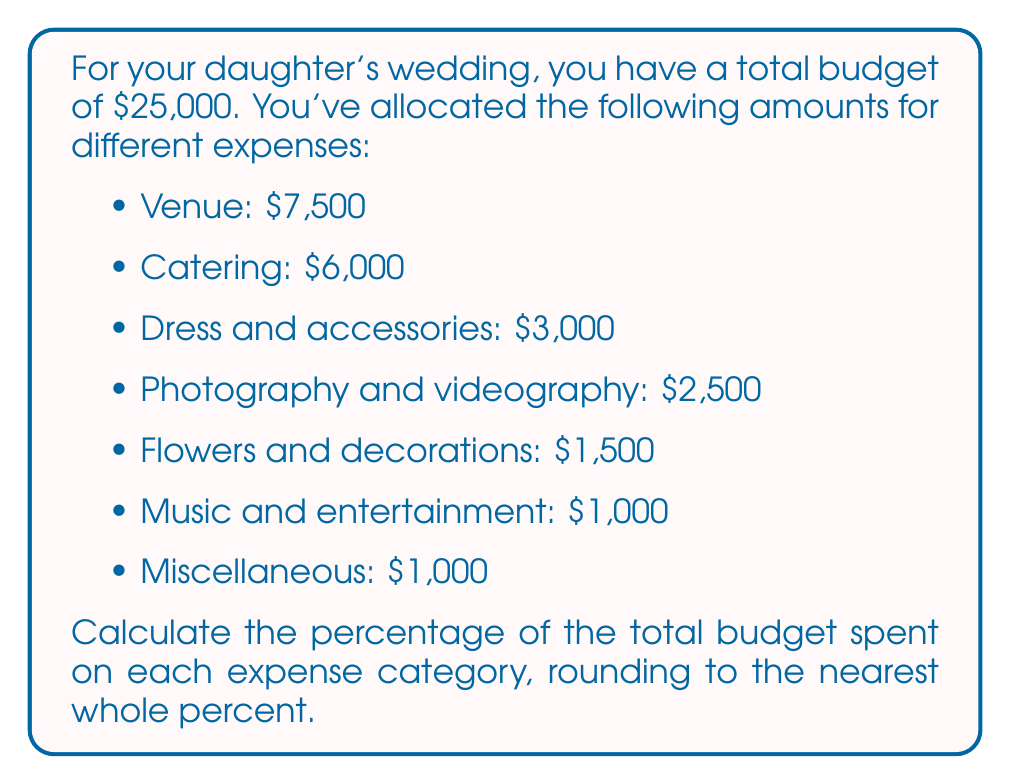Teach me how to tackle this problem. To calculate the percentage of the total budget spent on each expense category, we'll use the formula:

$$ \text{Percentage} = \frac{\text{Expense amount}}{\text{Total budget}} \times 100\% $$

Let's calculate for each category:

1. Venue:
   $$ \frac{7500}{25000} \times 100\% = 30\% $$

2. Catering:
   $$ \frac{6000}{25000} \times 100\% = 24\% $$

3. Dress and accessories:
   $$ \frac{3000}{25000} \times 100\% = 12\% $$

4. Photography and videography:
   $$ \frac{2500}{25000} \times 100\% = 10\% $$

5. Flowers and decorations:
   $$ \frac{1500}{25000} \times 100\% = 6\% $$

6. Music and entertainment:
   $$ \frac{1000}{25000} \times 100\% = 4\% $$

7. Miscellaneous:
   $$ \frac{1000}{25000} \times 100\% = 4\% $$

Note that the sum of all percentages should equal 100%. Let's verify:

$$ 30\% + 24\% + 12\% + 10\% + 6\% + 4\% + 4\% = 90\% $$

The remaining 10% is due to rounding to the nearest whole percent.
Answer: The percentages of the total budget spent on each expense category are:
- Venue: 30%
- Catering: 24%
- Dress and accessories: 12%
- Photography and videography: 10%
- Flowers and decorations: 6%
- Music and entertainment: 4%
- Miscellaneous: 4% 